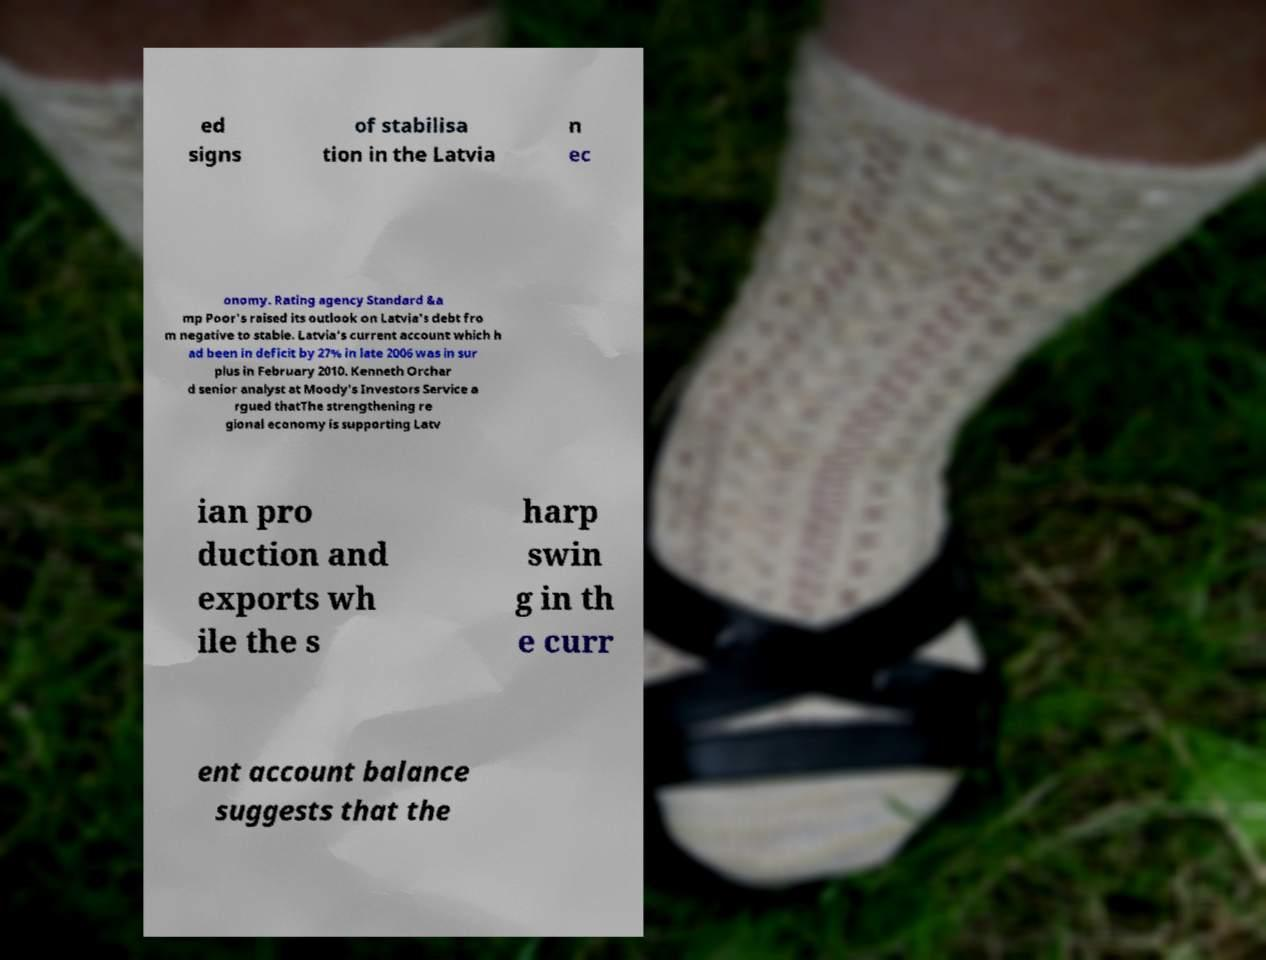Could you assist in decoding the text presented in this image and type it out clearly? ed signs of stabilisa tion in the Latvia n ec onomy. Rating agency Standard &a mp Poor's raised its outlook on Latvia's debt fro m negative to stable. Latvia's current account which h ad been in deficit by 27% in late 2006 was in sur plus in February 2010. Kenneth Orchar d senior analyst at Moody's Investors Service a rgued thatThe strengthening re gional economy is supporting Latv ian pro duction and exports wh ile the s harp swin g in th e curr ent account balance suggests that the 